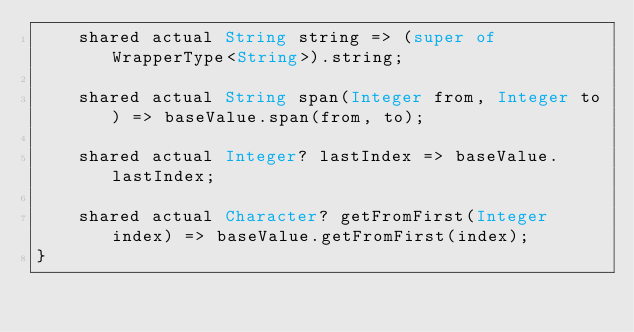<code> <loc_0><loc_0><loc_500><loc_500><_Ceylon_>    shared actual String string => (super of WrapperType<String>).string;
    
    shared actual String span(Integer from, Integer to) => baseValue.span(from, to);
    
    shared actual Integer? lastIndex => baseValue.lastIndex;
    
    shared actual Character? getFromFirst(Integer index) => baseValue.getFromFirst(index);
}
</code> 